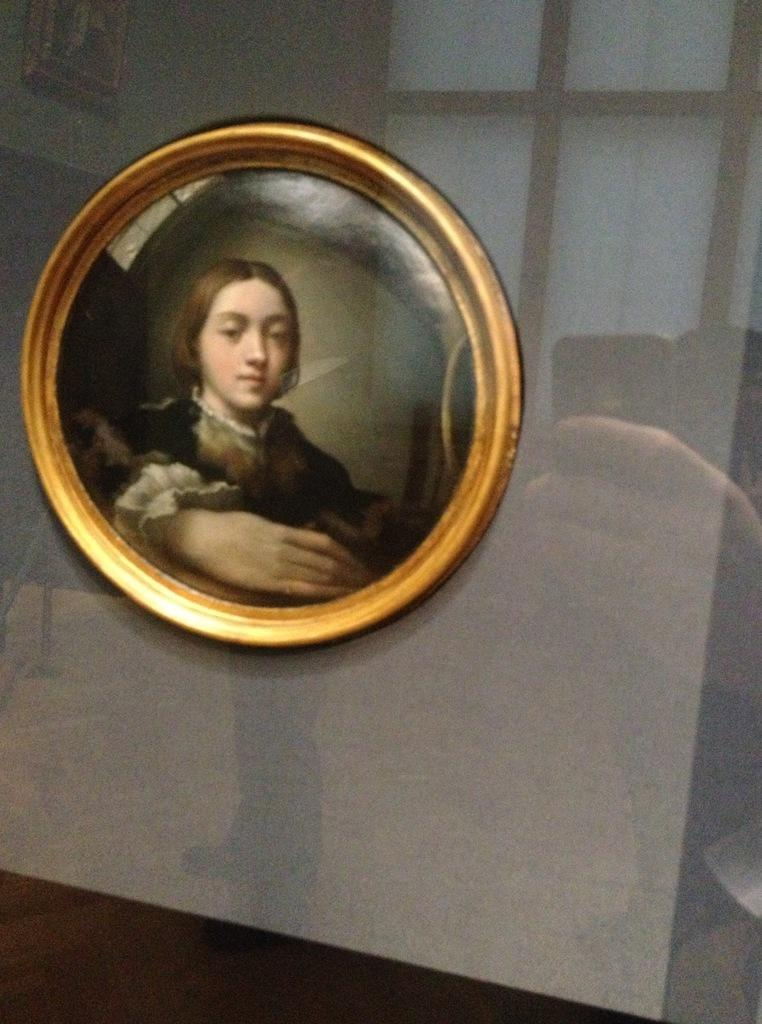What is the shape of the frame in the image? The frame in the image is round. What is contained within the frame? There is a picture inside the frame. What can be seen on the glass surrounding the frame? There is a reflection on the glass surrounding the frame. Where is the lunchroom located in the image? There is no mention of a lunchroom in the image, nor is there any indication of a lunchroom. 